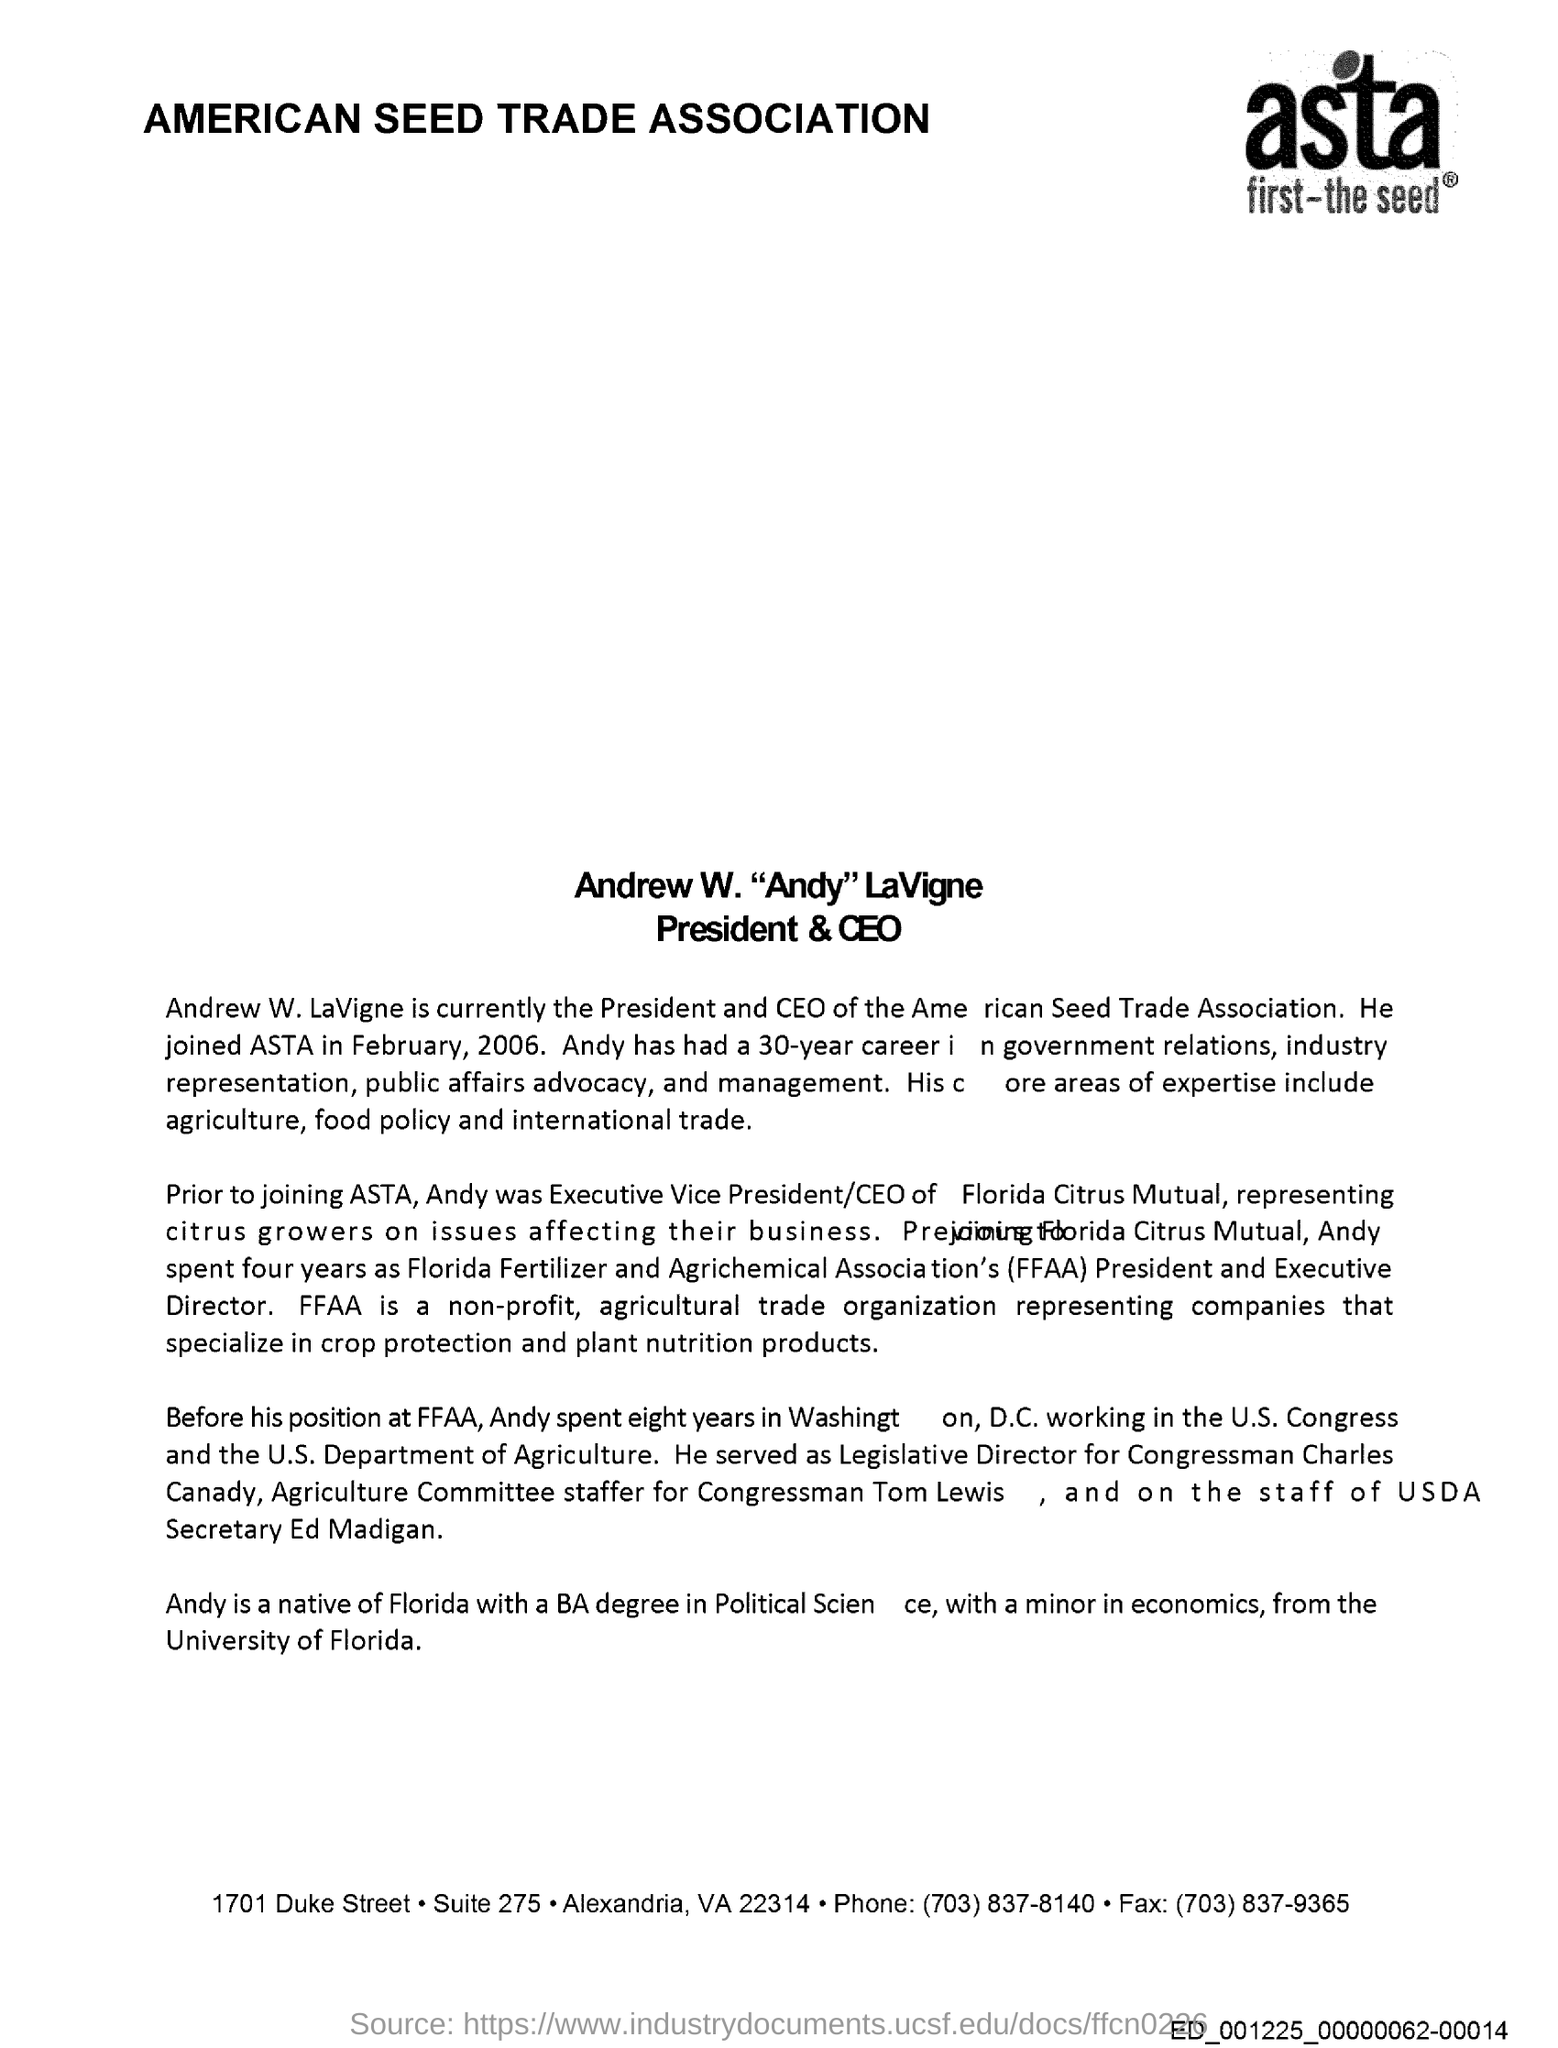Indicate a few pertinent items in this graphic. The Florida Fertilizer and Agrichemical Association (FFAA) is a well-established organization dedicated to promoting the interests and advancing the cause of fertilizer and agrichemical companies operating within the state of Florida. Andrew W. LaVigne is the current President and CEO of the American Seed Trade Association. I am proficient in the core areas of agriculture, food policy, and international trade. Andrew W. LaVigne joined ASTA in February 2006. 